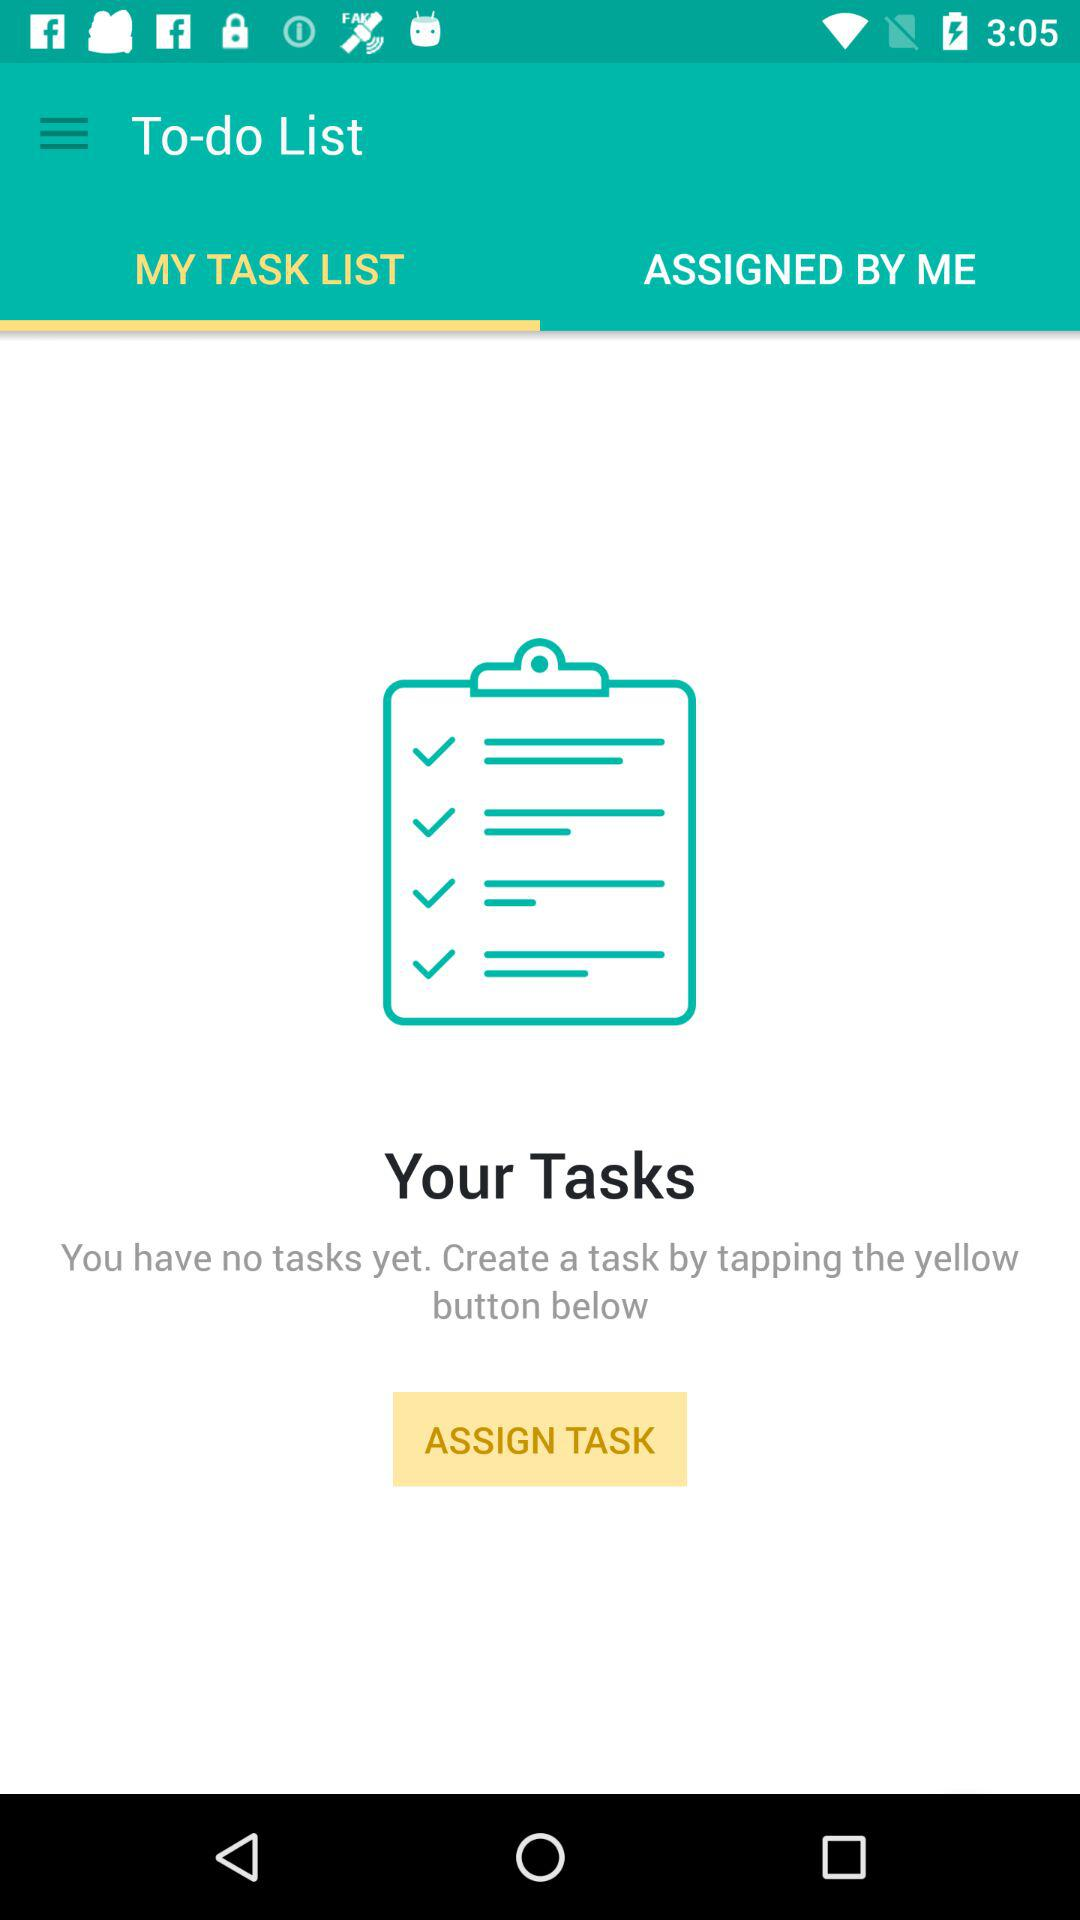Is there any task coming up? There is no task coming up. 